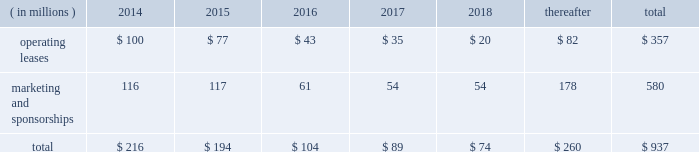Visa inc .
Notes to consolidated financial statements 2014 ( continued ) september 30 , 2013 market condition is based on the company 2019s total shareholder return ranked against that of other companies that are included in the standard & poor 2019s 500 index .
The fair value of the performance- based shares , incorporating the market condition , is estimated on the grant date using a monte carlo simulation model .
The grant-date fair value of performance-based shares in fiscal 2013 , 2012 and 2011 was $ 164.14 , $ 97.84 and $ 85.05 per share , respectively .
Earned performance shares granted in fiscal 2013 and 2012 vest approximately three years from the initial grant date .
Earned performance shares granted in fiscal 2011 vest in two equal installments approximately two and three years from their respective grant dates .
All performance awards are subject to earlier vesting in full under certain conditions .
Compensation cost for performance-based shares is initially estimated based on target performance .
It is recorded net of estimated forfeitures and adjusted as appropriate throughout the performance period .
At september 30 , 2013 , there was $ 15 million of total unrecognized compensation cost related to unvested performance-based shares , which is expected to be recognized over a weighted-average period of approximately 1.0 years .
Note 17 2014commitments and contingencies commitments .
The company leases certain premises and equipment throughout the world with varying expiration dates .
The company incurred total rent expense of $ 94 million , $ 89 million and $ 76 million in fiscal 2013 , 2012 and 2011 , respectively .
Future minimum payments on leases , and marketing and sponsorship agreements per fiscal year , at september 30 , 2013 , are as follows: .
Select sponsorship agreements require the company to spend certain minimum amounts for advertising and marketing promotion over the life of the contract .
For commitments where the individual years of spend are not specified in the contract , the company has estimated the timing of when these amounts will be spent .
In addition to the fixed payments stated above , select sponsorship agreements require the company to undertake marketing , promotional or other activities up to stated monetary values to support events which the company is sponsoring .
The stated monetary value of these activities typically represents the value in the marketplace , which may be significantly in excess of the actual costs incurred by the company .
Client incentives .
The company has agreements with financial institution clients and other business partners for various programs designed to build payments volume , increase visa-branded card and product acceptance and win merchant routing transactions .
These agreements , with original terms ranging from one to thirteen years , can provide card issuance and/or conversion support , volume/growth targets and marketing and program support based on specific performance requirements .
These agreements are designed to encourage client business and to increase overall visa-branded payment and transaction volume , thereby reducing per-unit transaction processing costs and increasing brand awareness for all visa clients .
Payments made that qualify for capitalization , and obligations incurred under these programs are reflected on the consolidated balance sheet .
Client incentives are recognized primarily as a reduction .
What is the percent increase in rent expense from 2012 to 2013? 
Computations: ((94 - 89) / 89)
Answer: 0.05618. 